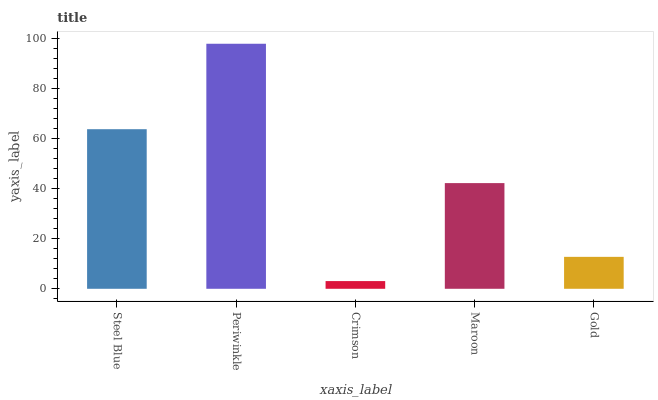Is Crimson the minimum?
Answer yes or no. Yes. Is Periwinkle the maximum?
Answer yes or no. Yes. Is Periwinkle the minimum?
Answer yes or no. No. Is Crimson the maximum?
Answer yes or no. No. Is Periwinkle greater than Crimson?
Answer yes or no. Yes. Is Crimson less than Periwinkle?
Answer yes or no. Yes. Is Crimson greater than Periwinkle?
Answer yes or no. No. Is Periwinkle less than Crimson?
Answer yes or no. No. Is Maroon the high median?
Answer yes or no. Yes. Is Maroon the low median?
Answer yes or no. Yes. Is Steel Blue the high median?
Answer yes or no. No. Is Steel Blue the low median?
Answer yes or no. No. 